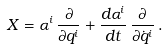<formula> <loc_0><loc_0><loc_500><loc_500>X = \alpha ^ { i } \, \frac { \partial } { \partial q ^ { i } } + \frac { d \alpha ^ { i } } { d t } \, \frac { \partial } { \partial \dot { q } ^ { i } } \, .</formula> 